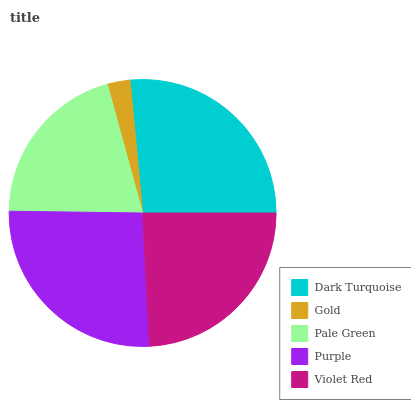Is Gold the minimum?
Answer yes or no. Yes. Is Dark Turquoise the maximum?
Answer yes or no. Yes. Is Pale Green the minimum?
Answer yes or no. No. Is Pale Green the maximum?
Answer yes or no. No. Is Pale Green greater than Gold?
Answer yes or no. Yes. Is Gold less than Pale Green?
Answer yes or no. Yes. Is Gold greater than Pale Green?
Answer yes or no. No. Is Pale Green less than Gold?
Answer yes or no. No. Is Violet Red the high median?
Answer yes or no. Yes. Is Violet Red the low median?
Answer yes or no. Yes. Is Dark Turquoise the high median?
Answer yes or no. No. Is Pale Green the low median?
Answer yes or no. No. 